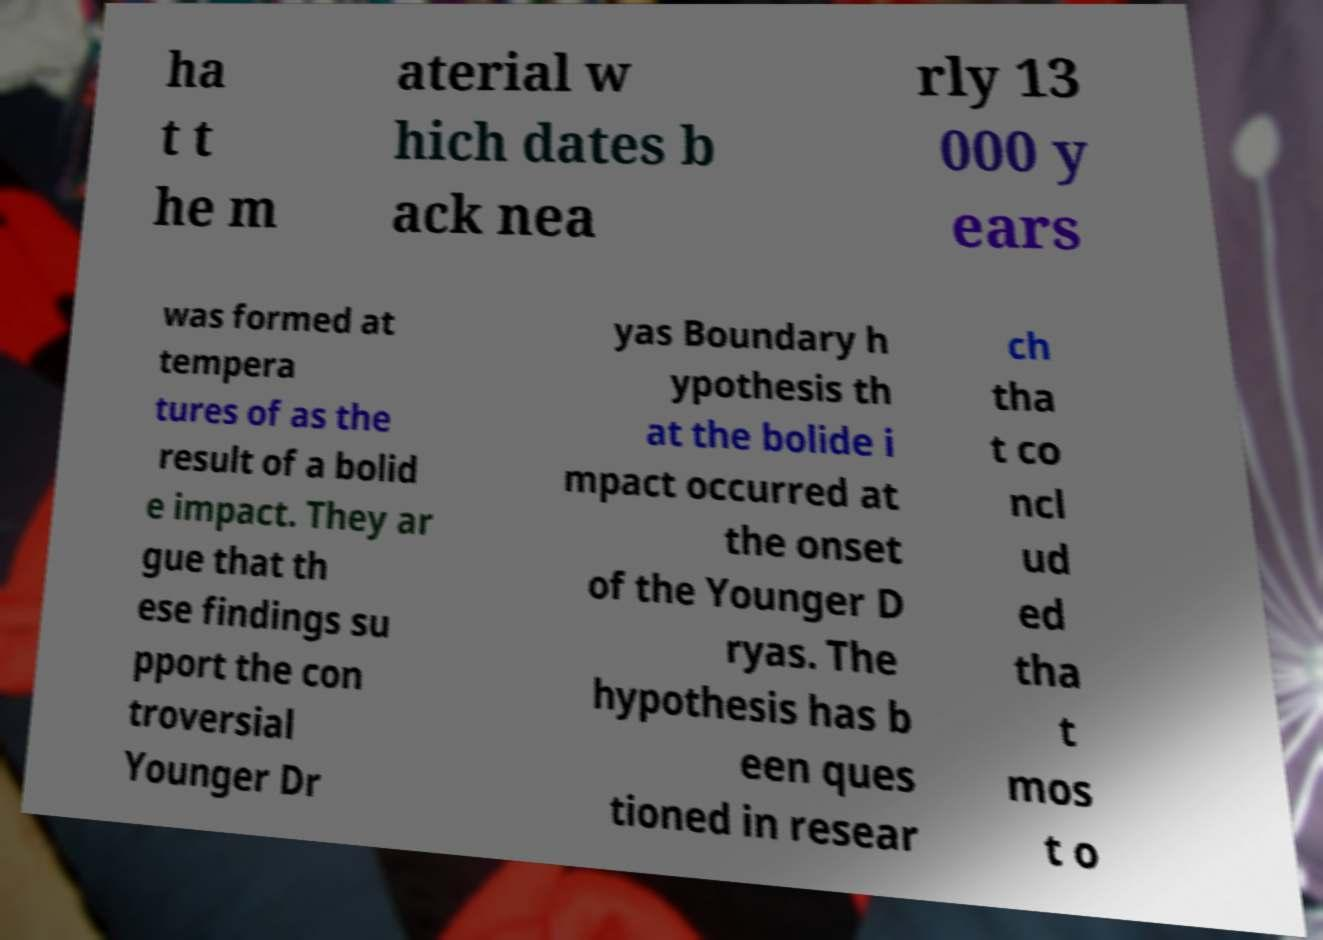There's text embedded in this image that I need extracted. Can you transcribe it verbatim? ha t t he m aterial w hich dates b ack nea rly 13 000 y ears was formed at tempera tures of as the result of a bolid e impact. They ar gue that th ese findings su pport the con troversial Younger Dr yas Boundary h ypothesis th at the bolide i mpact occurred at the onset of the Younger D ryas. The hypothesis has b een ques tioned in resear ch tha t co ncl ud ed tha t mos t o 